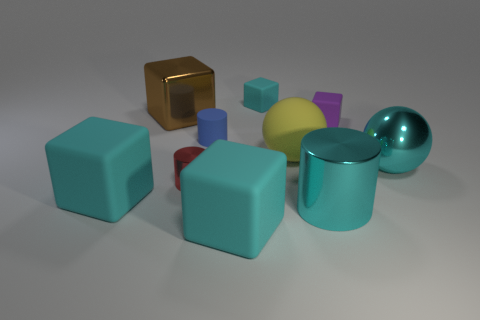Is there a blue object made of the same material as the yellow sphere?
Offer a terse response. Yes. What is the material of the blue cylinder that is the same size as the purple object?
Your answer should be very brief. Rubber. Are the tiny red thing and the small cyan block made of the same material?
Ensure brevity in your answer.  No. What number of objects are shiny blocks or tiny blocks?
Your answer should be compact. 3. What shape is the large cyan shiny object that is behind the big metal cylinder?
Provide a succinct answer. Sphere. The big sphere that is made of the same material as the blue object is what color?
Keep it short and to the point. Yellow. There is a small cyan object that is the same shape as the tiny purple rubber thing; what is it made of?
Offer a very short reply. Rubber. The big brown object is what shape?
Ensure brevity in your answer.  Cube. What is the object that is behind the large yellow thing and to the right of the small cyan object made of?
Offer a terse response. Rubber. There is a brown object that is the same material as the small red cylinder; what shape is it?
Provide a short and direct response. Cube. 